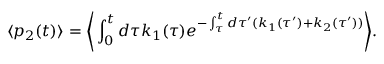Convert formula to latex. <formula><loc_0><loc_0><loc_500><loc_500>\langle p _ { 2 } ( t ) \rangle = \left \langle \int _ { 0 } ^ { t } d \tau k _ { 1 } ( \tau ) e ^ { - \int _ { \tau } ^ { t } d \tau ^ { \prime } ( k _ { 1 } ( \tau ^ { \prime } ) + k _ { 2 } ( \tau ^ { \prime } ) ) } \right \rangle .</formula> 